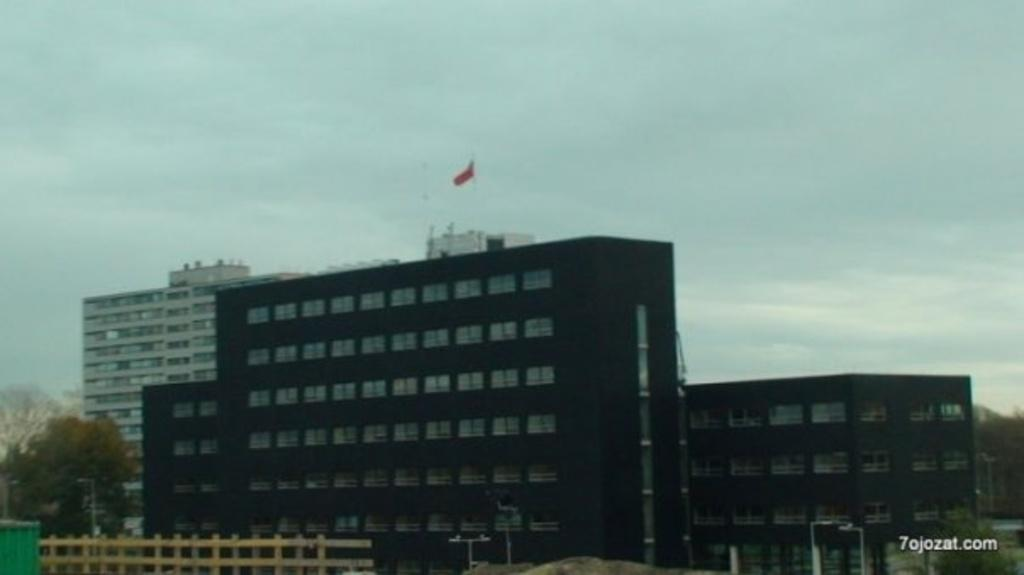What type of structures can be seen in the image? There are buildings in the image. Is there any symbol or emblem on any of the buildings? Yes, there is a flag on one of the buildings. What can be seen on the right side of the image? There is text visible on the right side of the image. What type of barrier is present on the left side of the image? There is a wooden fence on the left side of the image. What type of drink is being served by the laborer in the image? There is no laborer or drink present in the image. 